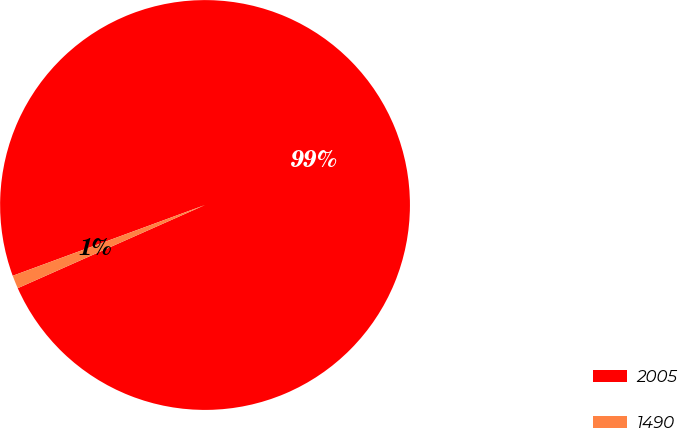Convert chart to OTSL. <chart><loc_0><loc_0><loc_500><loc_500><pie_chart><fcel>2005<fcel>1490<nl><fcel>98.96%<fcel>1.04%<nl></chart> 